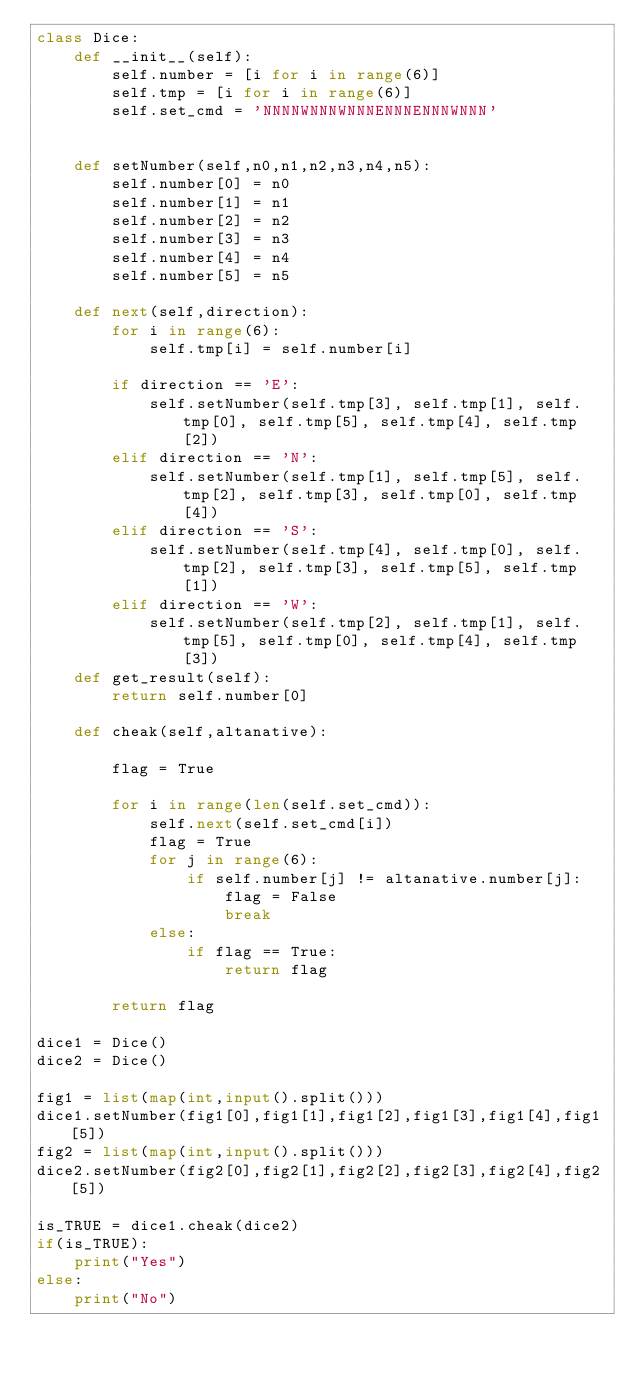Convert code to text. <code><loc_0><loc_0><loc_500><loc_500><_Python_>class Dice:
    def __init__(self):
        self.number = [i for i in range(6)]
        self.tmp = [i for i in range(6)]
        self.set_cmd = 'NNNNWNNNWNNNENNNENNNWNNN'


    def setNumber(self,n0,n1,n2,n3,n4,n5):
        self.number[0] = n0
        self.number[1] = n1
        self.number[2] = n2
        self.number[3] = n3
        self.number[4] = n4
        self.number[5] = n5

    def next(self,direction):
        for i in range(6):
            self.tmp[i] = self.number[i]

        if direction == 'E':
            self.setNumber(self.tmp[3], self.tmp[1], self.tmp[0], self.tmp[5], self.tmp[4], self.tmp[2])
        elif direction == 'N':
            self.setNumber(self.tmp[1], self.tmp[5], self.tmp[2], self.tmp[3], self.tmp[0], self.tmp[4])
        elif direction == 'S':
            self.setNumber(self.tmp[4], self.tmp[0], self.tmp[2], self.tmp[3], self.tmp[5], self.tmp[1])
        elif direction == 'W':
            self.setNumber(self.tmp[2], self.tmp[1], self.tmp[5], self.tmp[0], self.tmp[4], self.tmp[3])
    def get_result(self):
        return self.number[0]

    def cheak(self,altanative):

        flag = True

        for i in range(len(self.set_cmd)):
            self.next(self.set_cmd[i])
            flag = True
            for j in range(6):
                if self.number[j] != altanative.number[j]:
                    flag = False
                    break
            else:
                if flag == True:
                    return flag

        return flag

dice1 = Dice()
dice2 = Dice()

fig1 = list(map(int,input().split()))
dice1.setNumber(fig1[0],fig1[1],fig1[2],fig1[3],fig1[4],fig1[5])
fig2 = list(map(int,input().split()))
dice2.setNumber(fig2[0],fig2[1],fig2[2],fig2[3],fig2[4],fig2[5])

is_TRUE = dice1.cheak(dice2)
if(is_TRUE):
    print("Yes")
else:
    print("No")











</code> 